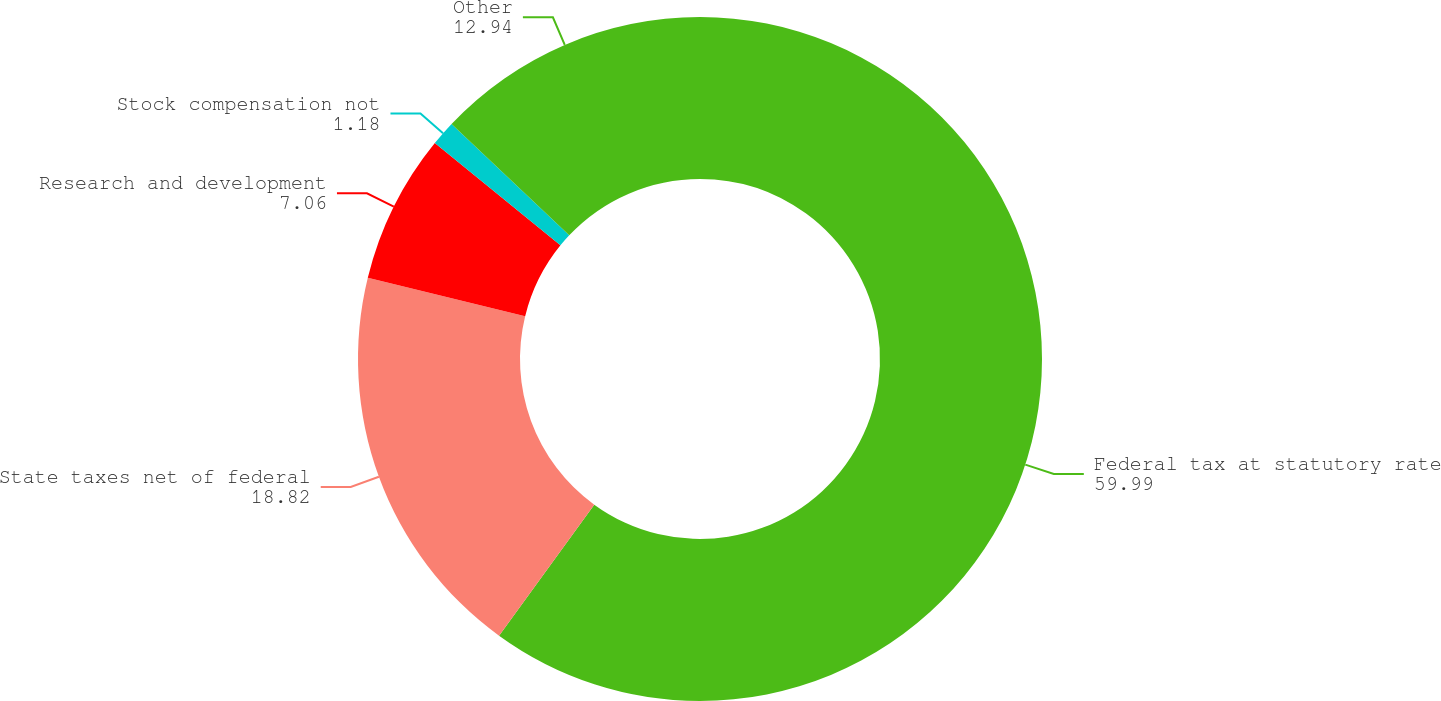<chart> <loc_0><loc_0><loc_500><loc_500><pie_chart><fcel>Federal tax at statutory rate<fcel>State taxes net of federal<fcel>Research and development<fcel>Stock compensation not<fcel>Other<nl><fcel>59.99%<fcel>18.82%<fcel>7.06%<fcel>1.18%<fcel>12.94%<nl></chart> 